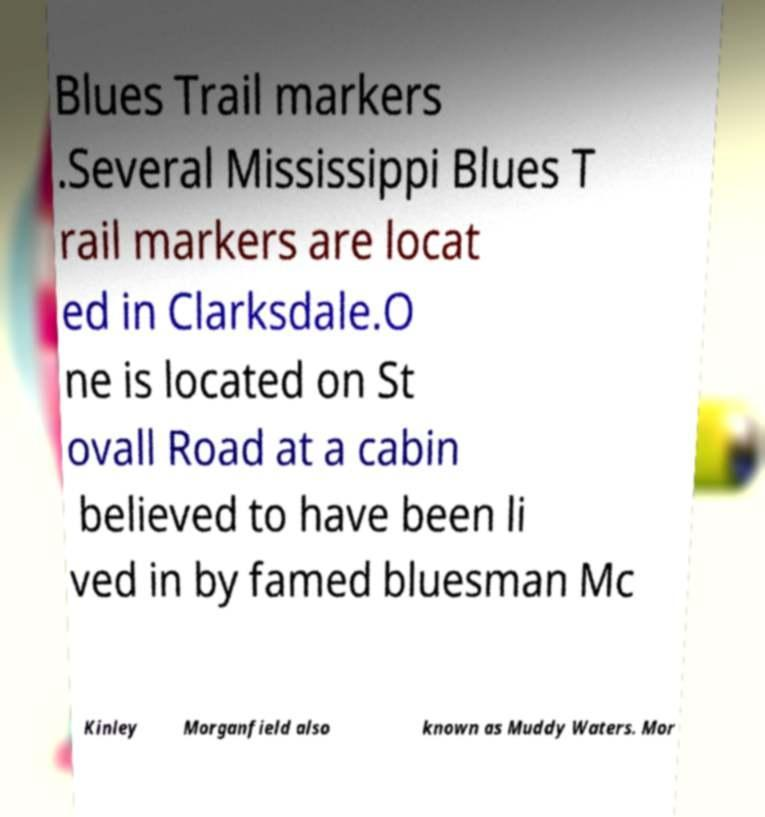For documentation purposes, I need the text within this image transcribed. Could you provide that? Blues Trail markers .Several Mississippi Blues T rail markers are locat ed in Clarksdale.O ne is located on St ovall Road at a cabin believed to have been li ved in by famed bluesman Mc Kinley Morganfield also known as Muddy Waters. Mor 